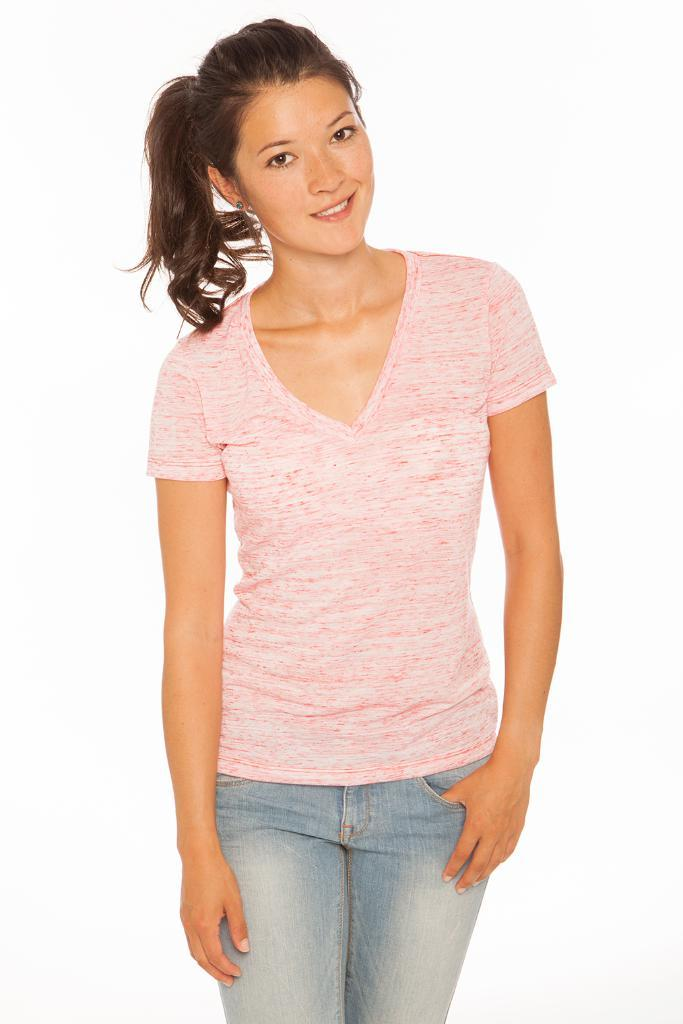Who is present in the image? There is a woman in the image. What is the woman doing in the image? The woman is standing in the image. What is the expression on the woman's face? The woman is smiling in the image. What color is the background of the image? The background of the image is white. What type of furniture is the woman using to support herself in the image? There is no furniture present in the image; the woman is standing on her own. What kind of fruit can be seen in the woman's hand in the image? There is no fruit present in the image; the woman is not holding anything. 